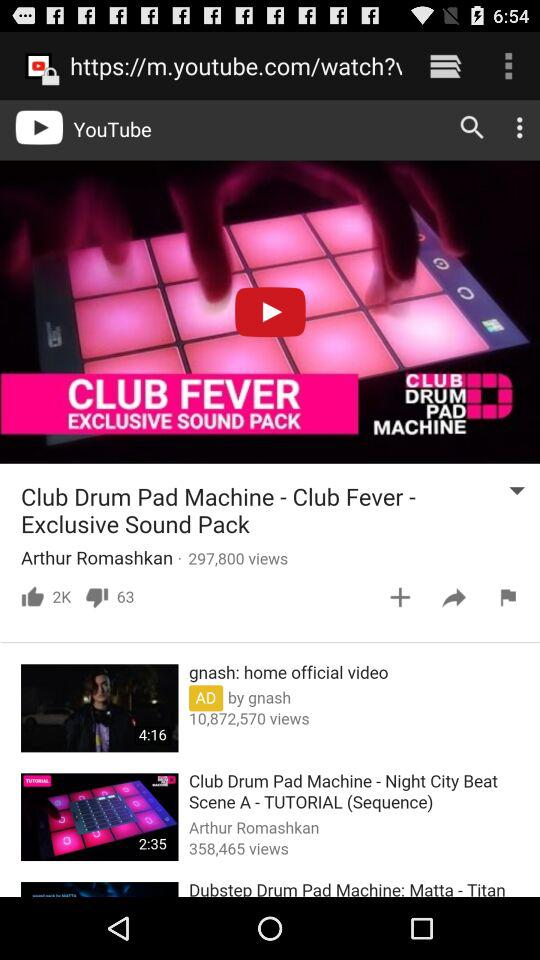What is the title of the current video?
Answer the question using a single word or phrase. What is the title of the current video? 